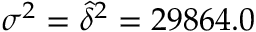Convert formula to latex. <formula><loc_0><loc_0><loc_500><loc_500>\sigma ^ { 2 } = \widehat { \delta } ^ { 2 } = 2 9 8 6 4 . 0</formula> 